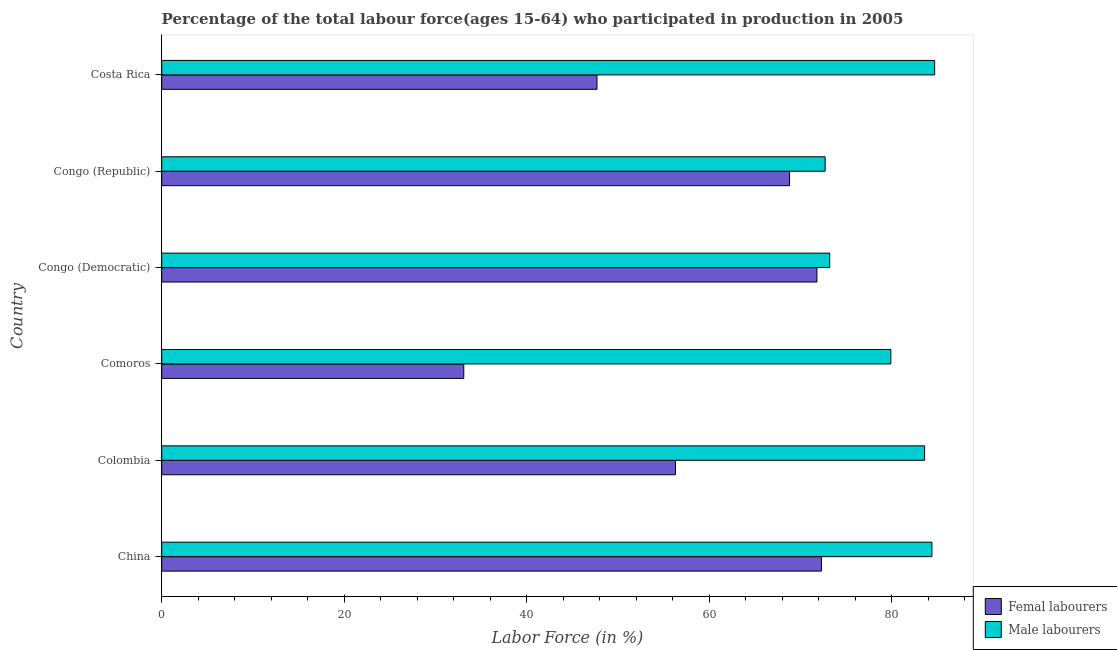Are the number of bars on each tick of the Y-axis equal?
Your response must be concise. Yes. How many bars are there on the 4th tick from the top?
Make the answer very short. 2. How many bars are there on the 4th tick from the bottom?
Provide a short and direct response. 2. What is the label of the 3rd group of bars from the top?
Make the answer very short. Congo (Democratic). In how many cases, is the number of bars for a given country not equal to the number of legend labels?
Make the answer very short. 0. What is the percentage of male labour force in Comoros?
Your response must be concise. 79.9. Across all countries, what is the maximum percentage of female labor force?
Provide a short and direct response. 72.3. Across all countries, what is the minimum percentage of female labor force?
Offer a terse response. 33.1. In which country was the percentage of female labor force minimum?
Keep it short and to the point. Comoros. What is the total percentage of male labour force in the graph?
Provide a short and direct response. 478.5. What is the difference between the percentage of male labour force in Comoros and that in Congo (Republic)?
Offer a terse response. 7.2. What is the difference between the percentage of male labour force in Colombia and the percentage of female labor force in Comoros?
Offer a terse response. 50.5. What is the average percentage of male labour force per country?
Provide a short and direct response. 79.75. In how many countries, is the percentage of female labor force greater than 28 %?
Your answer should be compact. 6. What is the ratio of the percentage of female labor force in Comoros to that in Congo (Republic)?
Offer a terse response. 0.48. Is the percentage of female labor force in Comoros less than that in Costa Rica?
Provide a short and direct response. Yes. Is the difference between the percentage of male labour force in Colombia and Congo (Democratic) greater than the difference between the percentage of female labor force in Colombia and Congo (Democratic)?
Provide a succinct answer. Yes. What is the difference between the highest and the second highest percentage of male labour force?
Make the answer very short. 0.3. What is the difference between the highest and the lowest percentage of male labour force?
Provide a succinct answer. 12. What does the 1st bar from the top in Comoros represents?
Keep it short and to the point. Male labourers. What does the 2nd bar from the bottom in Congo (Democratic) represents?
Your response must be concise. Male labourers. How many bars are there?
Keep it short and to the point. 12. Are all the bars in the graph horizontal?
Offer a very short reply. Yes. How many countries are there in the graph?
Give a very brief answer. 6. Are the values on the major ticks of X-axis written in scientific E-notation?
Provide a succinct answer. No. Does the graph contain any zero values?
Keep it short and to the point. No. Does the graph contain grids?
Provide a short and direct response. No. Where does the legend appear in the graph?
Offer a terse response. Bottom right. How many legend labels are there?
Ensure brevity in your answer.  2. How are the legend labels stacked?
Your answer should be compact. Vertical. What is the title of the graph?
Keep it short and to the point. Percentage of the total labour force(ages 15-64) who participated in production in 2005. Does "Rural" appear as one of the legend labels in the graph?
Give a very brief answer. No. What is the Labor Force (in %) of Femal labourers in China?
Give a very brief answer. 72.3. What is the Labor Force (in %) of Male labourers in China?
Provide a short and direct response. 84.4. What is the Labor Force (in %) in Femal labourers in Colombia?
Ensure brevity in your answer.  56.3. What is the Labor Force (in %) of Male labourers in Colombia?
Ensure brevity in your answer.  83.6. What is the Labor Force (in %) in Femal labourers in Comoros?
Offer a terse response. 33.1. What is the Labor Force (in %) of Male labourers in Comoros?
Your answer should be very brief. 79.9. What is the Labor Force (in %) in Femal labourers in Congo (Democratic)?
Make the answer very short. 71.8. What is the Labor Force (in %) of Male labourers in Congo (Democratic)?
Keep it short and to the point. 73.2. What is the Labor Force (in %) of Femal labourers in Congo (Republic)?
Offer a terse response. 68.8. What is the Labor Force (in %) of Male labourers in Congo (Republic)?
Your answer should be very brief. 72.7. What is the Labor Force (in %) in Femal labourers in Costa Rica?
Ensure brevity in your answer.  47.7. What is the Labor Force (in %) of Male labourers in Costa Rica?
Give a very brief answer. 84.7. Across all countries, what is the maximum Labor Force (in %) in Femal labourers?
Your answer should be compact. 72.3. Across all countries, what is the maximum Labor Force (in %) in Male labourers?
Your answer should be compact. 84.7. Across all countries, what is the minimum Labor Force (in %) of Femal labourers?
Your answer should be compact. 33.1. Across all countries, what is the minimum Labor Force (in %) in Male labourers?
Give a very brief answer. 72.7. What is the total Labor Force (in %) of Femal labourers in the graph?
Keep it short and to the point. 350. What is the total Labor Force (in %) of Male labourers in the graph?
Keep it short and to the point. 478.5. What is the difference between the Labor Force (in %) in Femal labourers in China and that in Colombia?
Make the answer very short. 16. What is the difference between the Labor Force (in %) in Male labourers in China and that in Colombia?
Make the answer very short. 0.8. What is the difference between the Labor Force (in %) of Femal labourers in China and that in Comoros?
Your answer should be very brief. 39.2. What is the difference between the Labor Force (in %) of Male labourers in China and that in Comoros?
Your response must be concise. 4.5. What is the difference between the Labor Force (in %) in Femal labourers in China and that in Congo (Republic)?
Provide a succinct answer. 3.5. What is the difference between the Labor Force (in %) of Femal labourers in China and that in Costa Rica?
Your response must be concise. 24.6. What is the difference between the Labor Force (in %) of Male labourers in China and that in Costa Rica?
Your answer should be very brief. -0.3. What is the difference between the Labor Force (in %) of Femal labourers in Colombia and that in Comoros?
Your response must be concise. 23.2. What is the difference between the Labor Force (in %) of Femal labourers in Colombia and that in Congo (Democratic)?
Keep it short and to the point. -15.5. What is the difference between the Labor Force (in %) in Femal labourers in Colombia and that in Congo (Republic)?
Provide a succinct answer. -12.5. What is the difference between the Labor Force (in %) in Femal labourers in Colombia and that in Costa Rica?
Your response must be concise. 8.6. What is the difference between the Labor Force (in %) of Femal labourers in Comoros and that in Congo (Democratic)?
Your answer should be compact. -38.7. What is the difference between the Labor Force (in %) in Femal labourers in Comoros and that in Congo (Republic)?
Make the answer very short. -35.7. What is the difference between the Labor Force (in %) of Femal labourers in Comoros and that in Costa Rica?
Offer a terse response. -14.6. What is the difference between the Labor Force (in %) in Male labourers in Congo (Democratic) and that in Congo (Republic)?
Your response must be concise. 0.5. What is the difference between the Labor Force (in %) of Femal labourers in Congo (Democratic) and that in Costa Rica?
Offer a terse response. 24.1. What is the difference between the Labor Force (in %) in Femal labourers in Congo (Republic) and that in Costa Rica?
Give a very brief answer. 21.1. What is the difference between the Labor Force (in %) of Femal labourers in China and the Labor Force (in %) of Male labourers in Colombia?
Offer a very short reply. -11.3. What is the difference between the Labor Force (in %) of Femal labourers in China and the Labor Force (in %) of Male labourers in Costa Rica?
Offer a very short reply. -12.4. What is the difference between the Labor Force (in %) of Femal labourers in Colombia and the Labor Force (in %) of Male labourers in Comoros?
Make the answer very short. -23.6. What is the difference between the Labor Force (in %) of Femal labourers in Colombia and the Labor Force (in %) of Male labourers in Congo (Democratic)?
Make the answer very short. -16.9. What is the difference between the Labor Force (in %) of Femal labourers in Colombia and the Labor Force (in %) of Male labourers in Congo (Republic)?
Give a very brief answer. -16.4. What is the difference between the Labor Force (in %) of Femal labourers in Colombia and the Labor Force (in %) of Male labourers in Costa Rica?
Provide a short and direct response. -28.4. What is the difference between the Labor Force (in %) in Femal labourers in Comoros and the Labor Force (in %) in Male labourers in Congo (Democratic)?
Your answer should be compact. -40.1. What is the difference between the Labor Force (in %) of Femal labourers in Comoros and the Labor Force (in %) of Male labourers in Congo (Republic)?
Your answer should be very brief. -39.6. What is the difference between the Labor Force (in %) in Femal labourers in Comoros and the Labor Force (in %) in Male labourers in Costa Rica?
Your response must be concise. -51.6. What is the difference between the Labor Force (in %) of Femal labourers in Congo (Republic) and the Labor Force (in %) of Male labourers in Costa Rica?
Your answer should be compact. -15.9. What is the average Labor Force (in %) of Femal labourers per country?
Offer a terse response. 58.33. What is the average Labor Force (in %) in Male labourers per country?
Your answer should be compact. 79.75. What is the difference between the Labor Force (in %) of Femal labourers and Labor Force (in %) of Male labourers in Colombia?
Make the answer very short. -27.3. What is the difference between the Labor Force (in %) of Femal labourers and Labor Force (in %) of Male labourers in Comoros?
Your answer should be very brief. -46.8. What is the difference between the Labor Force (in %) in Femal labourers and Labor Force (in %) in Male labourers in Congo (Democratic)?
Provide a short and direct response. -1.4. What is the difference between the Labor Force (in %) in Femal labourers and Labor Force (in %) in Male labourers in Congo (Republic)?
Your answer should be very brief. -3.9. What is the difference between the Labor Force (in %) in Femal labourers and Labor Force (in %) in Male labourers in Costa Rica?
Offer a very short reply. -37. What is the ratio of the Labor Force (in %) in Femal labourers in China to that in Colombia?
Provide a short and direct response. 1.28. What is the ratio of the Labor Force (in %) in Male labourers in China to that in Colombia?
Give a very brief answer. 1.01. What is the ratio of the Labor Force (in %) of Femal labourers in China to that in Comoros?
Your response must be concise. 2.18. What is the ratio of the Labor Force (in %) in Male labourers in China to that in Comoros?
Offer a very short reply. 1.06. What is the ratio of the Labor Force (in %) of Male labourers in China to that in Congo (Democratic)?
Provide a succinct answer. 1.15. What is the ratio of the Labor Force (in %) of Femal labourers in China to that in Congo (Republic)?
Offer a very short reply. 1.05. What is the ratio of the Labor Force (in %) of Male labourers in China to that in Congo (Republic)?
Your response must be concise. 1.16. What is the ratio of the Labor Force (in %) in Femal labourers in China to that in Costa Rica?
Keep it short and to the point. 1.52. What is the ratio of the Labor Force (in %) of Male labourers in China to that in Costa Rica?
Your response must be concise. 1. What is the ratio of the Labor Force (in %) of Femal labourers in Colombia to that in Comoros?
Provide a short and direct response. 1.7. What is the ratio of the Labor Force (in %) of Male labourers in Colombia to that in Comoros?
Give a very brief answer. 1.05. What is the ratio of the Labor Force (in %) in Femal labourers in Colombia to that in Congo (Democratic)?
Offer a terse response. 0.78. What is the ratio of the Labor Force (in %) of Male labourers in Colombia to that in Congo (Democratic)?
Keep it short and to the point. 1.14. What is the ratio of the Labor Force (in %) of Femal labourers in Colombia to that in Congo (Republic)?
Provide a short and direct response. 0.82. What is the ratio of the Labor Force (in %) in Male labourers in Colombia to that in Congo (Republic)?
Keep it short and to the point. 1.15. What is the ratio of the Labor Force (in %) in Femal labourers in Colombia to that in Costa Rica?
Ensure brevity in your answer.  1.18. What is the ratio of the Labor Force (in %) in Femal labourers in Comoros to that in Congo (Democratic)?
Your answer should be very brief. 0.46. What is the ratio of the Labor Force (in %) in Male labourers in Comoros to that in Congo (Democratic)?
Your answer should be very brief. 1.09. What is the ratio of the Labor Force (in %) in Femal labourers in Comoros to that in Congo (Republic)?
Offer a very short reply. 0.48. What is the ratio of the Labor Force (in %) of Male labourers in Comoros to that in Congo (Republic)?
Your answer should be very brief. 1.1. What is the ratio of the Labor Force (in %) in Femal labourers in Comoros to that in Costa Rica?
Provide a short and direct response. 0.69. What is the ratio of the Labor Force (in %) of Male labourers in Comoros to that in Costa Rica?
Your response must be concise. 0.94. What is the ratio of the Labor Force (in %) of Femal labourers in Congo (Democratic) to that in Congo (Republic)?
Keep it short and to the point. 1.04. What is the ratio of the Labor Force (in %) in Male labourers in Congo (Democratic) to that in Congo (Republic)?
Ensure brevity in your answer.  1.01. What is the ratio of the Labor Force (in %) of Femal labourers in Congo (Democratic) to that in Costa Rica?
Offer a terse response. 1.51. What is the ratio of the Labor Force (in %) of Male labourers in Congo (Democratic) to that in Costa Rica?
Your response must be concise. 0.86. What is the ratio of the Labor Force (in %) in Femal labourers in Congo (Republic) to that in Costa Rica?
Your answer should be compact. 1.44. What is the ratio of the Labor Force (in %) in Male labourers in Congo (Republic) to that in Costa Rica?
Ensure brevity in your answer.  0.86. What is the difference between the highest and the second highest Labor Force (in %) of Femal labourers?
Give a very brief answer. 0.5. What is the difference between the highest and the lowest Labor Force (in %) in Femal labourers?
Provide a short and direct response. 39.2. What is the difference between the highest and the lowest Labor Force (in %) of Male labourers?
Offer a terse response. 12. 